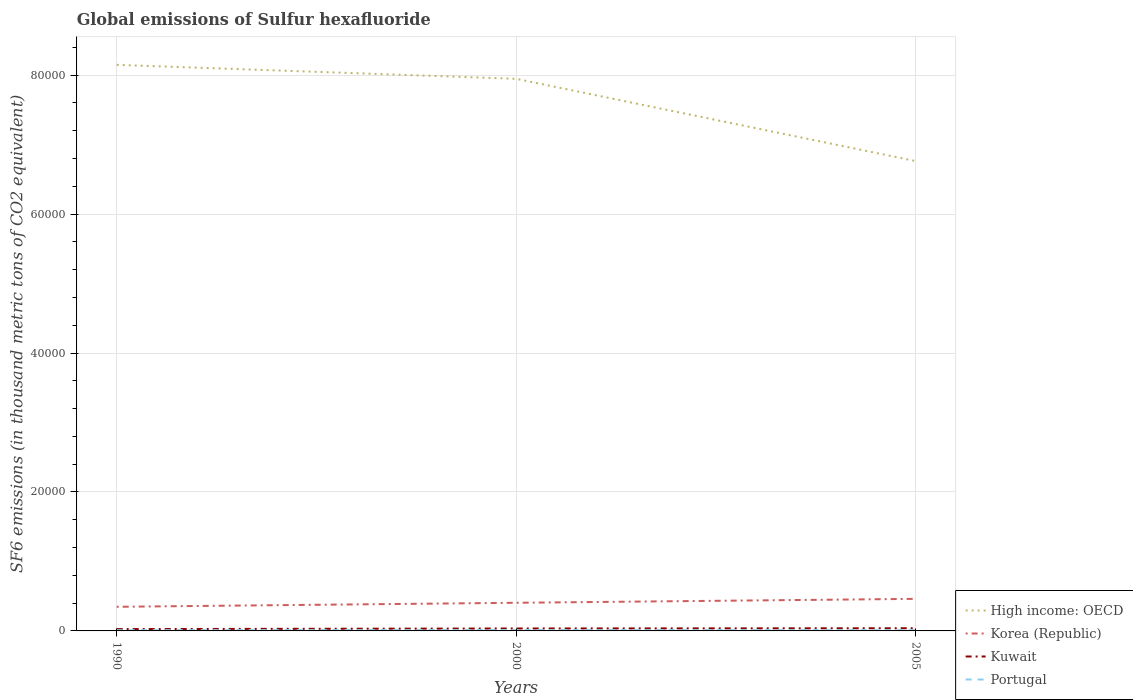How many different coloured lines are there?
Give a very brief answer. 4. Does the line corresponding to Kuwait intersect with the line corresponding to High income: OECD?
Give a very brief answer. No. Across all years, what is the maximum global emissions of Sulfur hexafluoride in Kuwait?
Your response must be concise. 263. In which year was the global emissions of Sulfur hexafluoride in Portugal maximum?
Your answer should be compact. 2005. What is the total global emissions of Sulfur hexafluoride in High income: OECD in the graph?
Ensure brevity in your answer.  1.18e+04. What is the difference between the highest and the second highest global emissions of Sulfur hexafluoride in High income: OECD?
Offer a terse response. 1.39e+04. What is the difference between the highest and the lowest global emissions of Sulfur hexafluoride in Kuwait?
Your response must be concise. 2. How many lines are there?
Give a very brief answer. 4. How many years are there in the graph?
Provide a succinct answer. 3. Are the values on the major ticks of Y-axis written in scientific E-notation?
Give a very brief answer. No. Does the graph contain grids?
Keep it short and to the point. Yes. How are the legend labels stacked?
Your answer should be very brief. Vertical. What is the title of the graph?
Your answer should be compact. Global emissions of Sulfur hexafluoride. What is the label or title of the X-axis?
Make the answer very short. Years. What is the label or title of the Y-axis?
Keep it short and to the point. SF6 emissions (in thousand metric tons of CO2 equivalent). What is the SF6 emissions (in thousand metric tons of CO2 equivalent) in High income: OECD in 1990?
Provide a succinct answer. 8.15e+04. What is the SF6 emissions (in thousand metric tons of CO2 equivalent) of Korea (Republic) in 1990?
Your answer should be compact. 3472.9. What is the SF6 emissions (in thousand metric tons of CO2 equivalent) in Kuwait in 1990?
Provide a short and direct response. 263. What is the SF6 emissions (in thousand metric tons of CO2 equivalent) of Portugal in 1990?
Provide a succinct answer. 108. What is the SF6 emissions (in thousand metric tons of CO2 equivalent) in High income: OECD in 2000?
Keep it short and to the point. 7.95e+04. What is the SF6 emissions (in thousand metric tons of CO2 equivalent) of Korea (Republic) in 2000?
Your answer should be compact. 4050.5. What is the SF6 emissions (in thousand metric tons of CO2 equivalent) in Kuwait in 2000?
Ensure brevity in your answer.  350.9. What is the SF6 emissions (in thousand metric tons of CO2 equivalent) in Portugal in 2000?
Ensure brevity in your answer.  128. What is the SF6 emissions (in thousand metric tons of CO2 equivalent) of High income: OECD in 2005?
Ensure brevity in your answer.  6.76e+04. What is the SF6 emissions (in thousand metric tons of CO2 equivalent) of Korea (Republic) in 2005?
Your response must be concise. 4615.7. What is the SF6 emissions (in thousand metric tons of CO2 equivalent) in Kuwait in 2005?
Make the answer very short. 386. What is the SF6 emissions (in thousand metric tons of CO2 equivalent) in Portugal in 2005?
Give a very brief answer. 103.8. Across all years, what is the maximum SF6 emissions (in thousand metric tons of CO2 equivalent) in High income: OECD?
Make the answer very short. 8.15e+04. Across all years, what is the maximum SF6 emissions (in thousand metric tons of CO2 equivalent) of Korea (Republic)?
Your response must be concise. 4615.7. Across all years, what is the maximum SF6 emissions (in thousand metric tons of CO2 equivalent) of Kuwait?
Your answer should be compact. 386. Across all years, what is the maximum SF6 emissions (in thousand metric tons of CO2 equivalent) in Portugal?
Your response must be concise. 128. Across all years, what is the minimum SF6 emissions (in thousand metric tons of CO2 equivalent) in High income: OECD?
Keep it short and to the point. 6.76e+04. Across all years, what is the minimum SF6 emissions (in thousand metric tons of CO2 equivalent) in Korea (Republic)?
Your response must be concise. 3472.9. Across all years, what is the minimum SF6 emissions (in thousand metric tons of CO2 equivalent) in Kuwait?
Give a very brief answer. 263. Across all years, what is the minimum SF6 emissions (in thousand metric tons of CO2 equivalent) of Portugal?
Your response must be concise. 103.8. What is the total SF6 emissions (in thousand metric tons of CO2 equivalent) of High income: OECD in the graph?
Keep it short and to the point. 2.29e+05. What is the total SF6 emissions (in thousand metric tons of CO2 equivalent) of Korea (Republic) in the graph?
Your answer should be very brief. 1.21e+04. What is the total SF6 emissions (in thousand metric tons of CO2 equivalent) of Kuwait in the graph?
Offer a terse response. 999.9. What is the total SF6 emissions (in thousand metric tons of CO2 equivalent) of Portugal in the graph?
Offer a terse response. 339.8. What is the difference between the SF6 emissions (in thousand metric tons of CO2 equivalent) in High income: OECD in 1990 and that in 2000?
Your answer should be very brief. 2011.1. What is the difference between the SF6 emissions (in thousand metric tons of CO2 equivalent) of Korea (Republic) in 1990 and that in 2000?
Keep it short and to the point. -577.6. What is the difference between the SF6 emissions (in thousand metric tons of CO2 equivalent) of Kuwait in 1990 and that in 2000?
Give a very brief answer. -87.9. What is the difference between the SF6 emissions (in thousand metric tons of CO2 equivalent) in High income: OECD in 1990 and that in 2005?
Your response must be concise. 1.39e+04. What is the difference between the SF6 emissions (in thousand metric tons of CO2 equivalent) in Korea (Republic) in 1990 and that in 2005?
Your answer should be compact. -1142.8. What is the difference between the SF6 emissions (in thousand metric tons of CO2 equivalent) in Kuwait in 1990 and that in 2005?
Your response must be concise. -123. What is the difference between the SF6 emissions (in thousand metric tons of CO2 equivalent) in High income: OECD in 2000 and that in 2005?
Your answer should be very brief. 1.18e+04. What is the difference between the SF6 emissions (in thousand metric tons of CO2 equivalent) of Korea (Republic) in 2000 and that in 2005?
Provide a succinct answer. -565.2. What is the difference between the SF6 emissions (in thousand metric tons of CO2 equivalent) in Kuwait in 2000 and that in 2005?
Give a very brief answer. -35.1. What is the difference between the SF6 emissions (in thousand metric tons of CO2 equivalent) in Portugal in 2000 and that in 2005?
Provide a succinct answer. 24.2. What is the difference between the SF6 emissions (in thousand metric tons of CO2 equivalent) in High income: OECD in 1990 and the SF6 emissions (in thousand metric tons of CO2 equivalent) in Korea (Republic) in 2000?
Ensure brevity in your answer.  7.74e+04. What is the difference between the SF6 emissions (in thousand metric tons of CO2 equivalent) of High income: OECD in 1990 and the SF6 emissions (in thousand metric tons of CO2 equivalent) of Kuwait in 2000?
Your answer should be compact. 8.11e+04. What is the difference between the SF6 emissions (in thousand metric tons of CO2 equivalent) of High income: OECD in 1990 and the SF6 emissions (in thousand metric tons of CO2 equivalent) of Portugal in 2000?
Provide a succinct answer. 8.13e+04. What is the difference between the SF6 emissions (in thousand metric tons of CO2 equivalent) in Korea (Republic) in 1990 and the SF6 emissions (in thousand metric tons of CO2 equivalent) in Kuwait in 2000?
Make the answer very short. 3122. What is the difference between the SF6 emissions (in thousand metric tons of CO2 equivalent) of Korea (Republic) in 1990 and the SF6 emissions (in thousand metric tons of CO2 equivalent) of Portugal in 2000?
Make the answer very short. 3344.9. What is the difference between the SF6 emissions (in thousand metric tons of CO2 equivalent) of Kuwait in 1990 and the SF6 emissions (in thousand metric tons of CO2 equivalent) of Portugal in 2000?
Provide a succinct answer. 135. What is the difference between the SF6 emissions (in thousand metric tons of CO2 equivalent) of High income: OECD in 1990 and the SF6 emissions (in thousand metric tons of CO2 equivalent) of Korea (Republic) in 2005?
Make the answer very short. 7.69e+04. What is the difference between the SF6 emissions (in thousand metric tons of CO2 equivalent) of High income: OECD in 1990 and the SF6 emissions (in thousand metric tons of CO2 equivalent) of Kuwait in 2005?
Provide a succinct answer. 8.11e+04. What is the difference between the SF6 emissions (in thousand metric tons of CO2 equivalent) in High income: OECD in 1990 and the SF6 emissions (in thousand metric tons of CO2 equivalent) in Portugal in 2005?
Make the answer very short. 8.14e+04. What is the difference between the SF6 emissions (in thousand metric tons of CO2 equivalent) in Korea (Republic) in 1990 and the SF6 emissions (in thousand metric tons of CO2 equivalent) in Kuwait in 2005?
Your response must be concise. 3086.9. What is the difference between the SF6 emissions (in thousand metric tons of CO2 equivalent) of Korea (Republic) in 1990 and the SF6 emissions (in thousand metric tons of CO2 equivalent) of Portugal in 2005?
Your answer should be very brief. 3369.1. What is the difference between the SF6 emissions (in thousand metric tons of CO2 equivalent) of Kuwait in 1990 and the SF6 emissions (in thousand metric tons of CO2 equivalent) of Portugal in 2005?
Make the answer very short. 159.2. What is the difference between the SF6 emissions (in thousand metric tons of CO2 equivalent) in High income: OECD in 2000 and the SF6 emissions (in thousand metric tons of CO2 equivalent) in Korea (Republic) in 2005?
Give a very brief answer. 7.48e+04. What is the difference between the SF6 emissions (in thousand metric tons of CO2 equivalent) of High income: OECD in 2000 and the SF6 emissions (in thousand metric tons of CO2 equivalent) of Kuwait in 2005?
Provide a short and direct response. 7.91e+04. What is the difference between the SF6 emissions (in thousand metric tons of CO2 equivalent) in High income: OECD in 2000 and the SF6 emissions (in thousand metric tons of CO2 equivalent) in Portugal in 2005?
Ensure brevity in your answer.  7.94e+04. What is the difference between the SF6 emissions (in thousand metric tons of CO2 equivalent) of Korea (Republic) in 2000 and the SF6 emissions (in thousand metric tons of CO2 equivalent) of Kuwait in 2005?
Offer a very short reply. 3664.5. What is the difference between the SF6 emissions (in thousand metric tons of CO2 equivalent) in Korea (Republic) in 2000 and the SF6 emissions (in thousand metric tons of CO2 equivalent) in Portugal in 2005?
Offer a very short reply. 3946.7. What is the difference between the SF6 emissions (in thousand metric tons of CO2 equivalent) of Kuwait in 2000 and the SF6 emissions (in thousand metric tons of CO2 equivalent) of Portugal in 2005?
Offer a very short reply. 247.1. What is the average SF6 emissions (in thousand metric tons of CO2 equivalent) in High income: OECD per year?
Your answer should be compact. 7.62e+04. What is the average SF6 emissions (in thousand metric tons of CO2 equivalent) in Korea (Republic) per year?
Keep it short and to the point. 4046.37. What is the average SF6 emissions (in thousand metric tons of CO2 equivalent) in Kuwait per year?
Ensure brevity in your answer.  333.3. What is the average SF6 emissions (in thousand metric tons of CO2 equivalent) of Portugal per year?
Provide a succinct answer. 113.27. In the year 1990, what is the difference between the SF6 emissions (in thousand metric tons of CO2 equivalent) of High income: OECD and SF6 emissions (in thousand metric tons of CO2 equivalent) of Korea (Republic)?
Provide a short and direct response. 7.80e+04. In the year 1990, what is the difference between the SF6 emissions (in thousand metric tons of CO2 equivalent) in High income: OECD and SF6 emissions (in thousand metric tons of CO2 equivalent) in Kuwait?
Offer a very short reply. 8.12e+04. In the year 1990, what is the difference between the SF6 emissions (in thousand metric tons of CO2 equivalent) of High income: OECD and SF6 emissions (in thousand metric tons of CO2 equivalent) of Portugal?
Provide a succinct answer. 8.14e+04. In the year 1990, what is the difference between the SF6 emissions (in thousand metric tons of CO2 equivalent) of Korea (Republic) and SF6 emissions (in thousand metric tons of CO2 equivalent) of Kuwait?
Offer a terse response. 3209.9. In the year 1990, what is the difference between the SF6 emissions (in thousand metric tons of CO2 equivalent) of Korea (Republic) and SF6 emissions (in thousand metric tons of CO2 equivalent) of Portugal?
Your answer should be compact. 3364.9. In the year 1990, what is the difference between the SF6 emissions (in thousand metric tons of CO2 equivalent) of Kuwait and SF6 emissions (in thousand metric tons of CO2 equivalent) of Portugal?
Your answer should be very brief. 155. In the year 2000, what is the difference between the SF6 emissions (in thousand metric tons of CO2 equivalent) of High income: OECD and SF6 emissions (in thousand metric tons of CO2 equivalent) of Korea (Republic)?
Ensure brevity in your answer.  7.54e+04. In the year 2000, what is the difference between the SF6 emissions (in thousand metric tons of CO2 equivalent) of High income: OECD and SF6 emissions (in thousand metric tons of CO2 equivalent) of Kuwait?
Offer a very short reply. 7.91e+04. In the year 2000, what is the difference between the SF6 emissions (in thousand metric tons of CO2 equivalent) of High income: OECD and SF6 emissions (in thousand metric tons of CO2 equivalent) of Portugal?
Ensure brevity in your answer.  7.93e+04. In the year 2000, what is the difference between the SF6 emissions (in thousand metric tons of CO2 equivalent) of Korea (Republic) and SF6 emissions (in thousand metric tons of CO2 equivalent) of Kuwait?
Offer a terse response. 3699.6. In the year 2000, what is the difference between the SF6 emissions (in thousand metric tons of CO2 equivalent) of Korea (Republic) and SF6 emissions (in thousand metric tons of CO2 equivalent) of Portugal?
Your response must be concise. 3922.5. In the year 2000, what is the difference between the SF6 emissions (in thousand metric tons of CO2 equivalent) of Kuwait and SF6 emissions (in thousand metric tons of CO2 equivalent) of Portugal?
Make the answer very short. 222.9. In the year 2005, what is the difference between the SF6 emissions (in thousand metric tons of CO2 equivalent) of High income: OECD and SF6 emissions (in thousand metric tons of CO2 equivalent) of Korea (Republic)?
Keep it short and to the point. 6.30e+04. In the year 2005, what is the difference between the SF6 emissions (in thousand metric tons of CO2 equivalent) of High income: OECD and SF6 emissions (in thousand metric tons of CO2 equivalent) of Kuwait?
Provide a succinct answer. 6.72e+04. In the year 2005, what is the difference between the SF6 emissions (in thousand metric tons of CO2 equivalent) in High income: OECD and SF6 emissions (in thousand metric tons of CO2 equivalent) in Portugal?
Offer a terse response. 6.75e+04. In the year 2005, what is the difference between the SF6 emissions (in thousand metric tons of CO2 equivalent) in Korea (Republic) and SF6 emissions (in thousand metric tons of CO2 equivalent) in Kuwait?
Give a very brief answer. 4229.7. In the year 2005, what is the difference between the SF6 emissions (in thousand metric tons of CO2 equivalent) in Korea (Republic) and SF6 emissions (in thousand metric tons of CO2 equivalent) in Portugal?
Your answer should be compact. 4511.9. In the year 2005, what is the difference between the SF6 emissions (in thousand metric tons of CO2 equivalent) in Kuwait and SF6 emissions (in thousand metric tons of CO2 equivalent) in Portugal?
Give a very brief answer. 282.2. What is the ratio of the SF6 emissions (in thousand metric tons of CO2 equivalent) in High income: OECD in 1990 to that in 2000?
Your response must be concise. 1.03. What is the ratio of the SF6 emissions (in thousand metric tons of CO2 equivalent) in Korea (Republic) in 1990 to that in 2000?
Provide a short and direct response. 0.86. What is the ratio of the SF6 emissions (in thousand metric tons of CO2 equivalent) in Kuwait in 1990 to that in 2000?
Ensure brevity in your answer.  0.75. What is the ratio of the SF6 emissions (in thousand metric tons of CO2 equivalent) in Portugal in 1990 to that in 2000?
Your answer should be very brief. 0.84. What is the ratio of the SF6 emissions (in thousand metric tons of CO2 equivalent) of High income: OECD in 1990 to that in 2005?
Your answer should be compact. 1.2. What is the ratio of the SF6 emissions (in thousand metric tons of CO2 equivalent) in Korea (Republic) in 1990 to that in 2005?
Provide a short and direct response. 0.75. What is the ratio of the SF6 emissions (in thousand metric tons of CO2 equivalent) of Kuwait in 1990 to that in 2005?
Provide a short and direct response. 0.68. What is the ratio of the SF6 emissions (in thousand metric tons of CO2 equivalent) of Portugal in 1990 to that in 2005?
Your response must be concise. 1.04. What is the ratio of the SF6 emissions (in thousand metric tons of CO2 equivalent) of High income: OECD in 2000 to that in 2005?
Offer a very short reply. 1.18. What is the ratio of the SF6 emissions (in thousand metric tons of CO2 equivalent) of Korea (Republic) in 2000 to that in 2005?
Your answer should be very brief. 0.88. What is the ratio of the SF6 emissions (in thousand metric tons of CO2 equivalent) in Kuwait in 2000 to that in 2005?
Offer a very short reply. 0.91. What is the ratio of the SF6 emissions (in thousand metric tons of CO2 equivalent) of Portugal in 2000 to that in 2005?
Offer a very short reply. 1.23. What is the difference between the highest and the second highest SF6 emissions (in thousand metric tons of CO2 equivalent) in High income: OECD?
Keep it short and to the point. 2011.1. What is the difference between the highest and the second highest SF6 emissions (in thousand metric tons of CO2 equivalent) in Korea (Republic)?
Ensure brevity in your answer.  565.2. What is the difference between the highest and the second highest SF6 emissions (in thousand metric tons of CO2 equivalent) in Kuwait?
Offer a very short reply. 35.1. What is the difference between the highest and the second highest SF6 emissions (in thousand metric tons of CO2 equivalent) in Portugal?
Ensure brevity in your answer.  20. What is the difference between the highest and the lowest SF6 emissions (in thousand metric tons of CO2 equivalent) in High income: OECD?
Make the answer very short. 1.39e+04. What is the difference between the highest and the lowest SF6 emissions (in thousand metric tons of CO2 equivalent) of Korea (Republic)?
Make the answer very short. 1142.8. What is the difference between the highest and the lowest SF6 emissions (in thousand metric tons of CO2 equivalent) in Kuwait?
Your response must be concise. 123. What is the difference between the highest and the lowest SF6 emissions (in thousand metric tons of CO2 equivalent) of Portugal?
Offer a terse response. 24.2. 